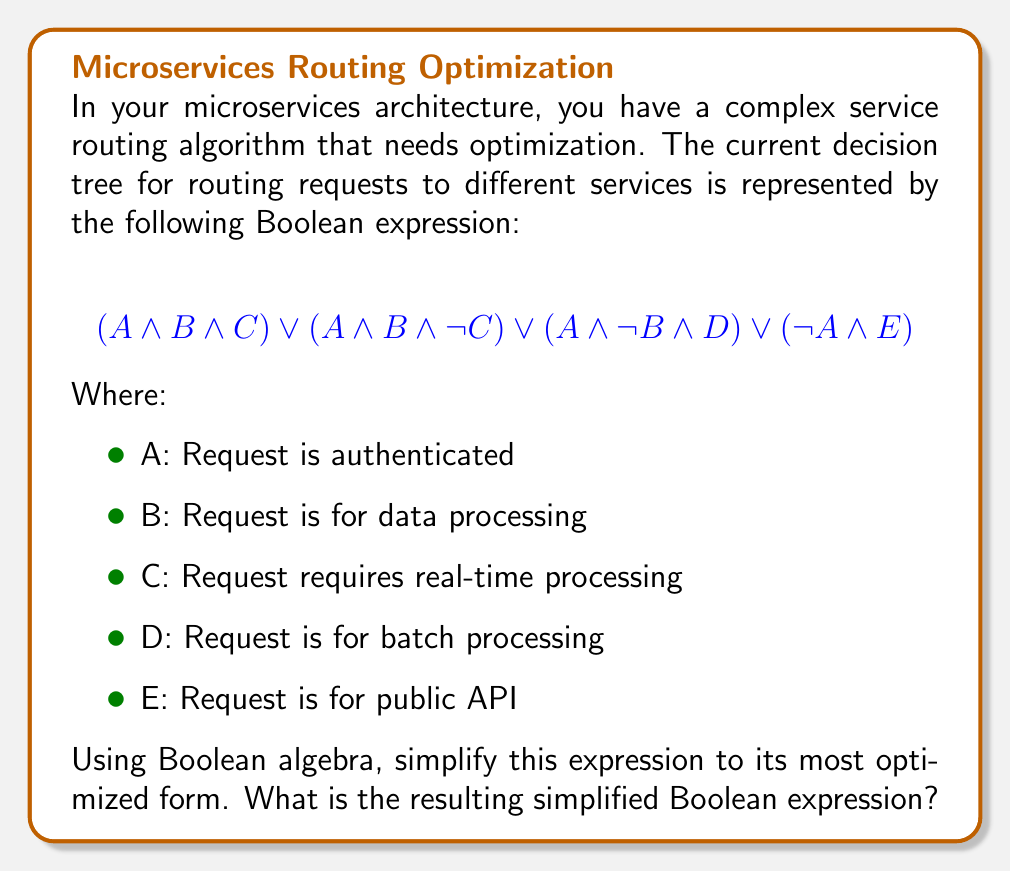Could you help me with this problem? Let's approach this step-by-step using Boolean algebra laws:

1) First, let's focus on the first two terms: $(A \land B \land C) \lor (A \land B \land \neg C)$
   We can factor out $(A \land B)$:
   $(A \land B) \land (C \lor \neg C)$
   
2) We know that $(C \lor \neg C) = 1$ (law of excluded middle), so this simplifies to:
   $(A \land B)$

3) Now our expression looks like this:
   $(A \land B) \lor (A \land \neg B \land D) \lor (\neg A \land E)$

4) We can't simplify further between these terms as they are mutually exclusive.

5) Therefore, our final simplified expression is:
   $(A \land B) \lor (A \land \neg B \land D) \lor (\neg A \land E)$

This simplified form reduces the number of logical operations needed to evaluate the routing decision, potentially improving the performance of your service routing algorithm.
Answer: $(A \land B) \lor (A \land \neg B \land D) \lor (\neg A \land E)$ 